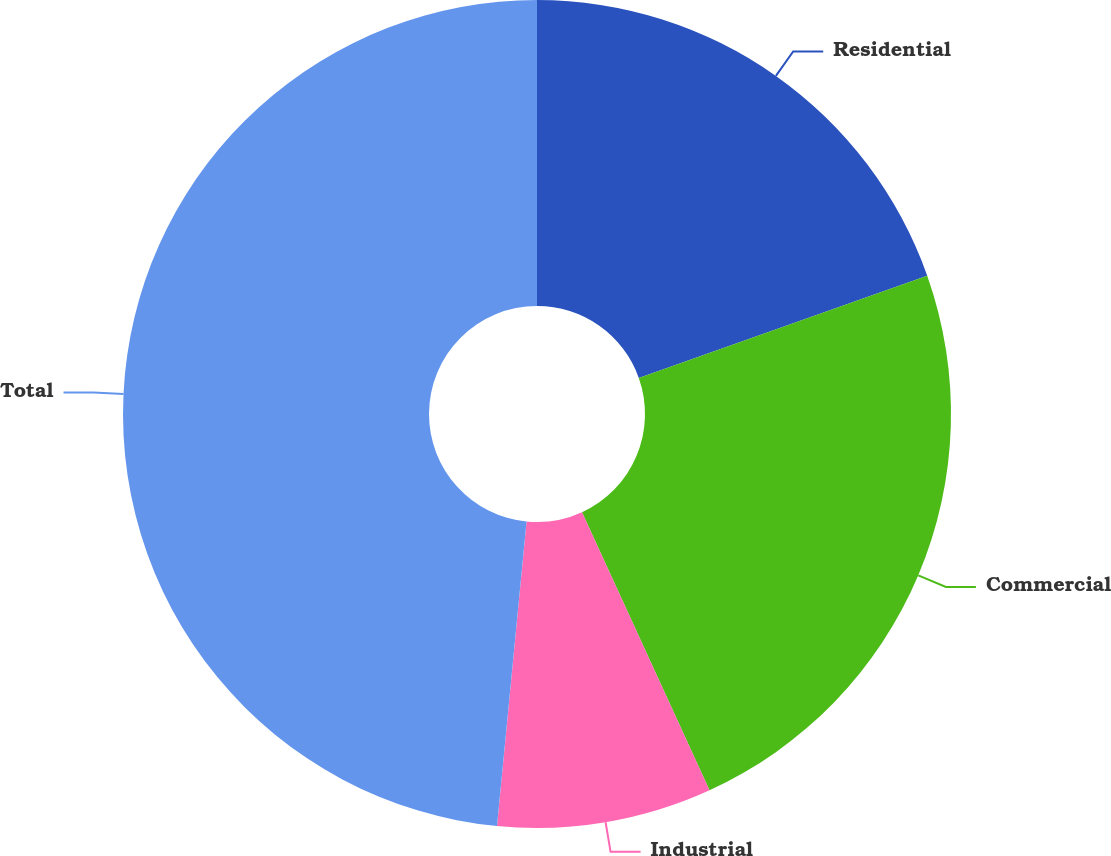<chart> <loc_0><loc_0><loc_500><loc_500><pie_chart><fcel>Residential<fcel>Commercial<fcel>Industrial<fcel>Total<nl><fcel>19.58%<fcel>23.58%<fcel>8.38%<fcel>48.46%<nl></chart> 